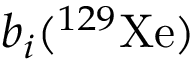Convert formula to latex. <formula><loc_0><loc_0><loc_500><loc_500>b _ { i } ( ^ { 1 2 9 } X e )</formula> 